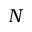<formula> <loc_0><loc_0><loc_500><loc_500>N</formula> 